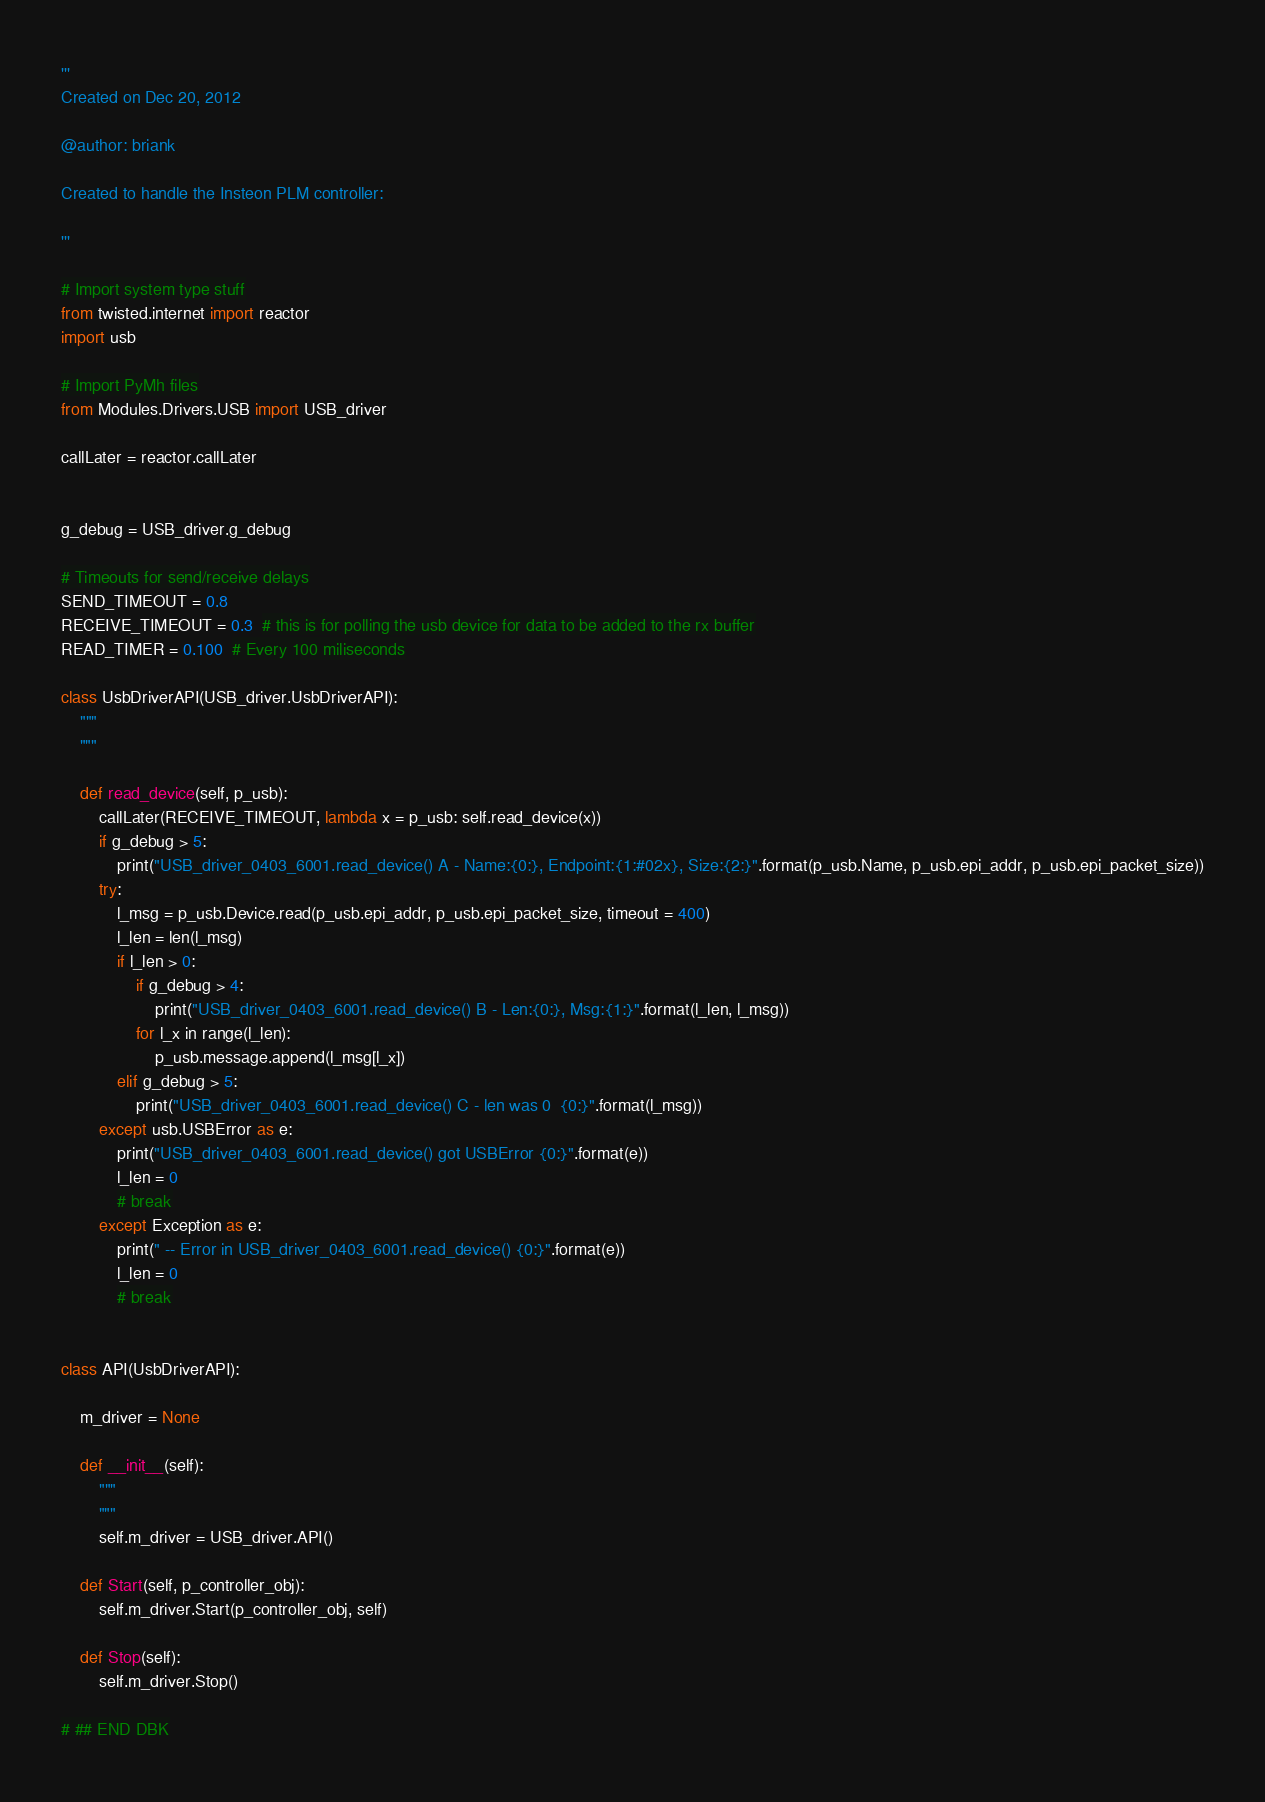<code> <loc_0><loc_0><loc_500><loc_500><_Python_>'''
Created on Dec 20, 2012

@author: briank

Created to handle the Insteon PLM controller:

'''

# Import system type stuff
from twisted.internet import reactor
import usb

# Import PyMh files
from Modules.Drivers.USB import USB_driver

callLater = reactor.callLater


g_debug = USB_driver.g_debug

# Timeouts for send/receive delays
SEND_TIMEOUT = 0.8
RECEIVE_TIMEOUT = 0.3  # this is for polling the usb device for data to be added to the rx buffer
READ_TIMER = 0.100  # Every 100 miliseconds

class UsbDriverAPI(USB_driver.UsbDriverAPI):
    """
    """

    def read_device(self, p_usb):
        callLater(RECEIVE_TIMEOUT, lambda x = p_usb: self.read_device(x))
        if g_debug > 5:
            print("USB_driver_0403_6001.read_device() A - Name:{0:}, Endpoint:{1:#02x}, Size:{2:}".format(p_usb.Name, p_usb.epi_addr, p_usb.epi_packet_size))
        try:
            l_msg = p_usb.Device.read(p_usb.epi_addr, p_usb.epi_packet_size, timeout = 400)
            l_len = len(l_msg)
            if l_len > 0:
                if g_debug > 4:
                    print("USB_driver_0403_6001.read_device() B - Len:{0:}, Msg:{1:}".format(l_len, l_msg))
                for l_x in range(l_len):
                    p_usb.message.append(l_msg[l_x])
            elif g_debug > 5:
                print("USB_driver_0403_6001.read_device() C - len was 0  {0:}".format(l_msg))
        except usb.USBError as e:
            print("USB_driver_0403_6001.read_device() got USBError {0:}".format(e))
            l_len = 0
            # break
        except Exception as e:
            print(" -- Error in USB_driver_0403_6001.read_device() {0:}".format(e))
            l_len = 0
            # break


class API(UsbDriverAPI):

    m_driver = None

    def __init__(self):
        """
        """
        self.m_driver = USB_driver.API()

    def Start(self, p_controller_obj):
        self.m_driver.Start(p_controller_obj, self)

    def Stop(self):
        self.m_driver.Stop()

# ## END DBK
</code> 